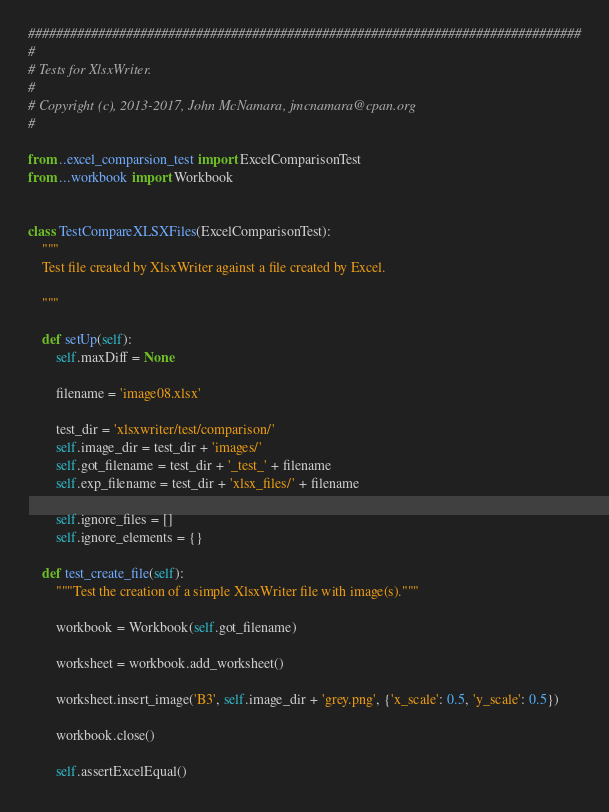Convert code to text. <code><loc_0><loc_0><loc_500><loc_500><_Python_>###############################################################################
#
# Tests for XlsxWriter.
#
# Copyright (c), 2013-2017, John McNamara, jmcnamara@cpan.org
#

from ..excel_comparsion_test import ExcelComparisonTest
from ...workbook import Workbook


class TestCompareXLSXFiles(ExcelComparisonTest):
    """
    Test file created by XlsxWriter against a file created by Excel.

    """

    def setUp(self):
        self.maxDiff = None

        filename = 'image08.xlsx'

        test_dir = 'xlsxwriter/test/comparison/'
        self.image_dir = test_dir + 'images/'
        self.got_filename = test_dir + '_test_' + filename
        self.exp_filename = test_dir + 'xlsx_files/' + filename

        self.ignore_files = []
        self.ignore_elements = {}

    def test_create_file(self):
        """Test the creation of a simple XlsxWriter file with image(s)."""

        workbook = Workbook(self.got_filename)

        worksheet = workbook.add_worksheet()

        worksheet.insert_image('B3', self.image_dir + 'grey.png', {'x_scale': 0.5, 'y_scale': 0.5})

        workbook.close()

        self.assertExcelEqual()
</code> 